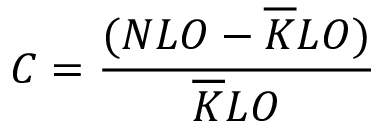<formula> <loc_0><loc_0><loc_500><loc_500>C = \frac { ( N L O - \overline { K } L O ) } { \overline { K } L O }</formula> 